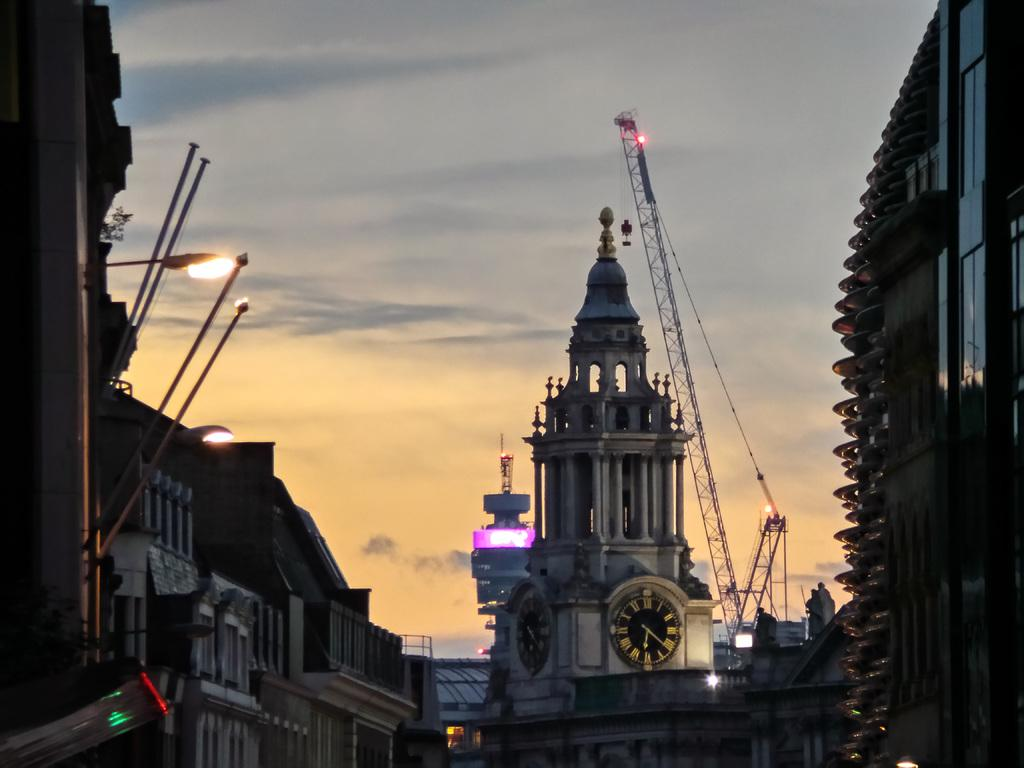What type of structures can be seen in the image? There are buildings in the image. What feature is common among many of the buildings? There are windows in the buildings. What type of street furniture is present in the image? There are light poles and poles in the image. What type of transportation is visible in the image? There are vehicles in the image. What type of construction equipment is present in the image? There are cranes in the image. What colors can be seen in the sky in the image? The sky is in orange, grey, and white colors. What type of texture can be seen on the brake of the vehicle in the image? There is no mention of a brake in the image, and therefore no texture can be observed on it. How much debt is associated with the construction project depicted in the image? There is no information about debt or a construction project in the image. 